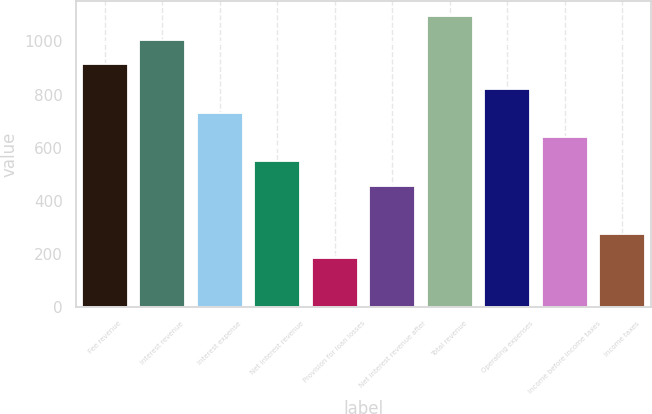Convert chart to OTSL. <chart><loc_0><loc_0><loc_500><loc_500><bar_chart><fcel>Fee revenue<fcel>Interest revenue<fcel>Interest expense<fcel>Net interest revenue<fcel>Provision for loan losses<fcel>Net interest revenue after<fcel>Total revenue<fcel>Operating expenses<fcel>Income before income taxes<fcel>Income taxes<nl><fcel>913.96<fcel>1005.31<fcel>731.26<fcel>548.56<fcel>183.16<fcel>457.21<fcel>1096.66<fcel>822.61<fcel>639.91<fcel>274.51<nl></chart> 